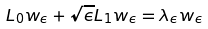Convert formula to latex. <formula><loc_0><loc_0><loc_500><loc_500>L _ { 0 } w _ { \epsilon } + \sqrt { \epsilon } L _ { 1 } w _ { \epsilon } = \lambda _ { \epsilon } w _ { \epsilon }</formula> 